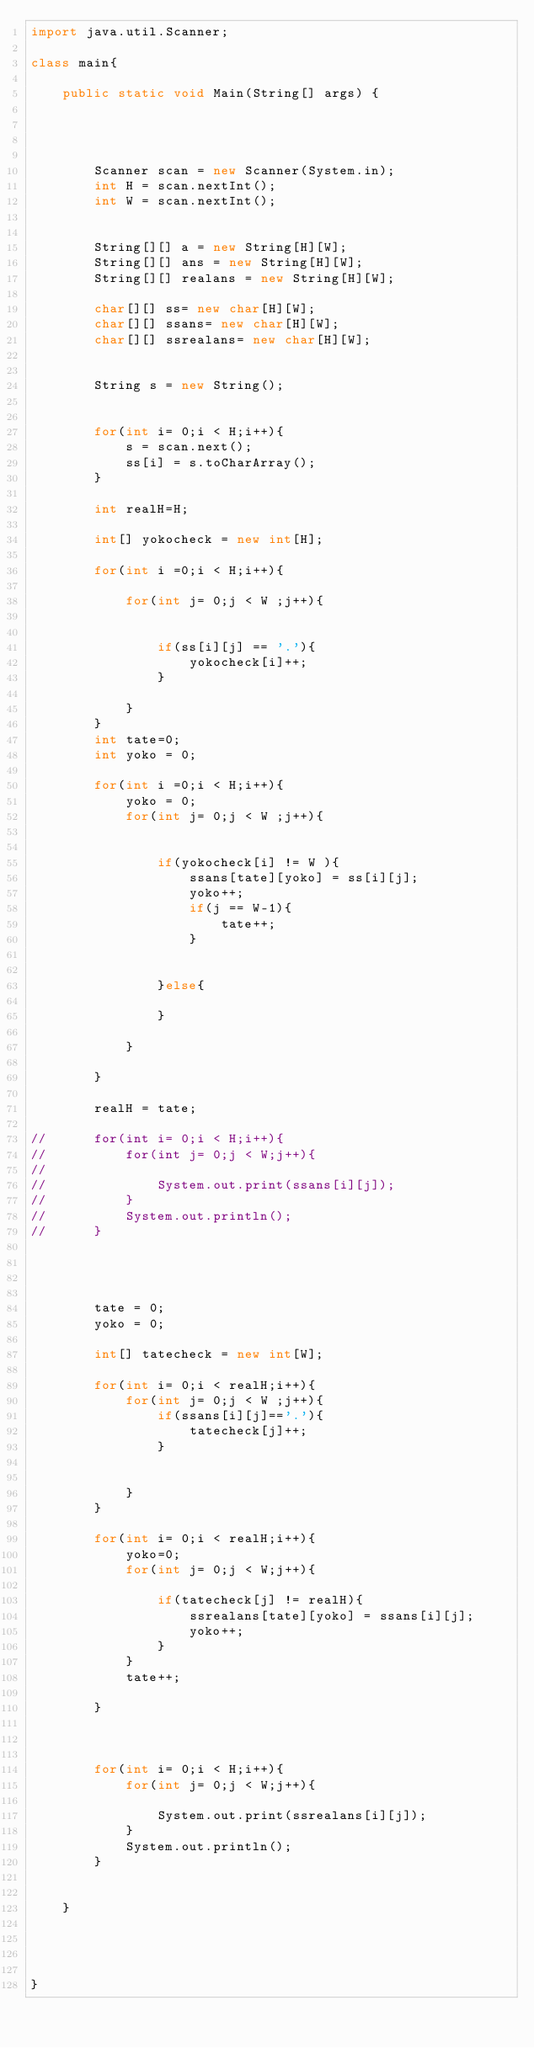<code> <loc_0><loc_0><loc_500><loc_500><_Java_>import java.util.Scanner;

class main{

	public static void Main(String[] args) {




		Scanner scan = new Scanner(System.in);
		int H = scan.nextInt();
		int W = scan.nextInt();


		String[][] a = new String[H][W]; 
		String[][] ans = new String[H][W]; 
		String[][] realans = new String[H][W]; 

		char[][] ss= new char[H][W];
		char[][] ssans= new char[H][W];
		char[][] ssrealans= new char[H][W];


		String s = new String();


		for(int i= 0;i < H;i++){
			s = scan.next();
			ss[i] = s.toCharArray();
		}

		int realH=H;

		int[] yokocheck = new int[H];

		for(int i =0;i < H;i++){

			for(int j= 0;j < W ;j++){


				if(ss[i][j] == '.'){
					yokocheck[i]++;
				}

			}
		}
		int tate=0;
		int yoko = 0;

		for(int i =0;i < H;i++){
			yoko = 0;
			for(int j= 0;j < W ;j++){


				if(yokocheck[i] != W ){
					ssans[tate][yoko] = ss[i][j];
					yoko++;
					if(j == W-1){
						tate++;
					}


				}else{
					
				}

			}

		}
		
		realH = tate;
		
//		for(int i= 0;i < H;i++){
//			for(int j= 0;j < W;j++){
//
//				System.out.print(ssans[i][j]);
//			}
//			System.out.println();
//		}


	

		tate = 0;
		yoko = 0;

		int[] tatecheck = new int[W];

		for(int i= 0;i < realH;i++){
			for(int j= 0;j < W ;j++){
				if(ssans[i][j]=='.'){
					tatecheck[j]++;			
				}


			}
		}

		for(int i= 0;i < realH;i++){
			yoko=0;
			for(int j= 0;j < W;j++){

				if(tatecheck[j] != realH){
					ssrealans[tate][yoko] = ssans[i][j];
					yoko++;
				}
			}
			tate++;

		}



		for(int i= 0;i < H;i++){
			for(int j= 0;j < W;j++){

				System.out.print(ssrealans[i][j]);
			}
			System.out.println();
		}


	}




}
</code> 